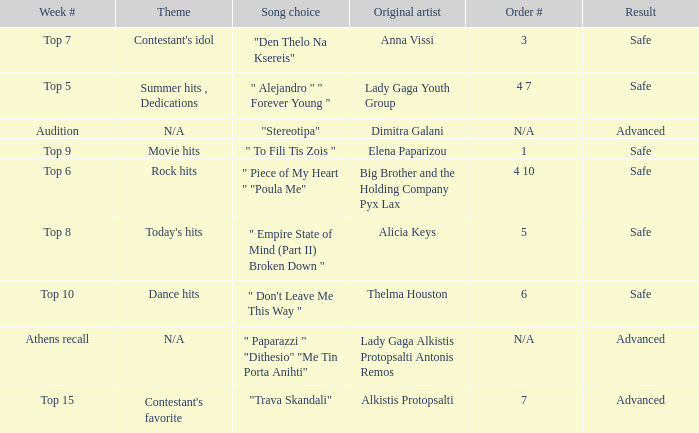Which week had the song choice " empire state of mind (part ii) broken down "? Top 8. 